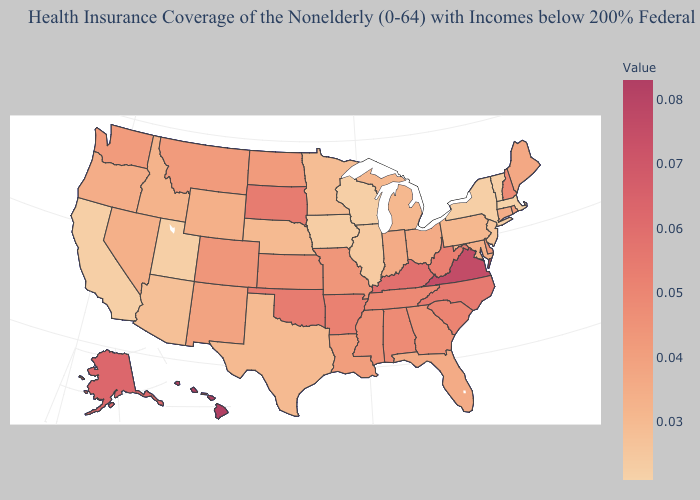Is the legend a continuous bar?
Short answer required. Yes. Among the states that border Utah , does Arizona have the lowest value?
Quick response, please. Yes. Among the states that border Alabama , which have the lowest value?
Quick response, please. Florida. Does South Carolina have the lowest value in the South?
Answer briefly. No. Is the legend a continuous bar?
Keep it brief. Yes. Among the states that border Delaware , which have the highest value?
Keep it brief. Maryland. 